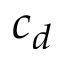<formula> <loc_0><loc_0><loc_500><loc_500>c _ { d }</formula> 